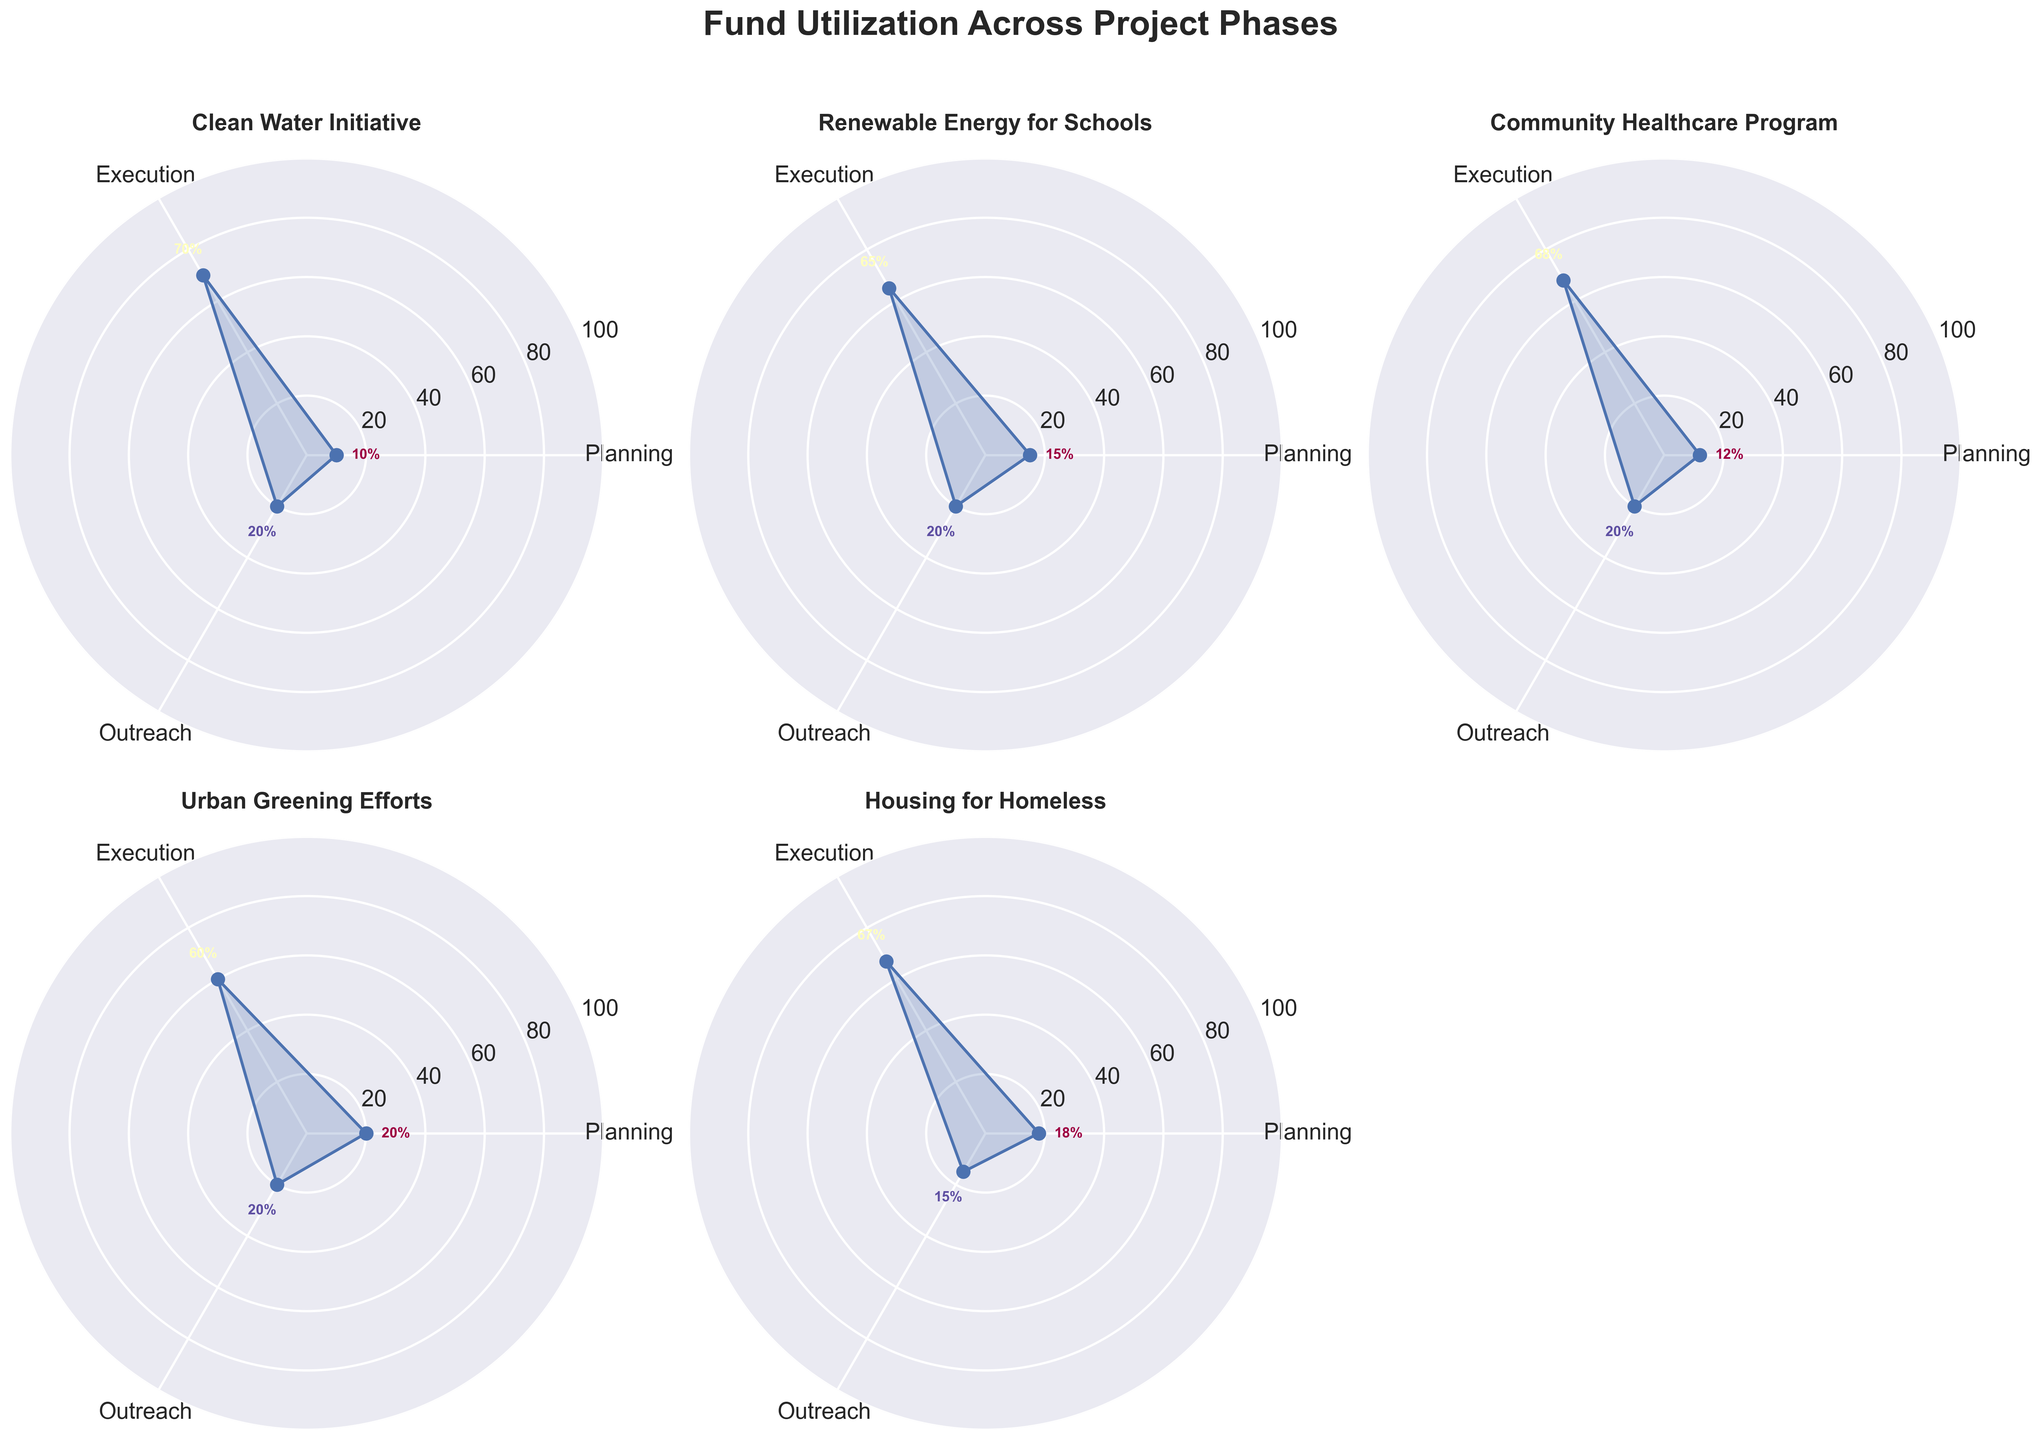Which project has the highest percentage of funds allocated to planning? To determine which project allocates the highest percentage of funds to planning, we compare the planning percentages across all the projects in the chart. The highest planning percentage is 20% for the "Urban Greening Efforts" project.
Answer: Urban Greening Efforts Which phase generally receives the least funding across all projects? By observing the plotted percentages across different phases (planning, execution, outreach) for all projects, the "Planning" phase tends to have the lowest percentages consistently across the projects.
Answer: Planning How does the fund allocation for the "Execution" phase in the "Clean Water Initiative" compare to the "Housing for Homeless" project? To compare the fund allocation in the execution phase, we look at the value of the percentage for each project. The "Execution" phase for "Clean Water Initiative" is 70%, while for "Housing for Homeless," it is 67%.
Answer: Clean Water Initiative has a higher execution percentage than Housing for Homeless Which project has the most balanced distribution of funds across the three phases? A balanced distribution would have the percentages for each phase close to each other. "Housing for Homeless" has percentages of 18%, 67%, and 15%, which is relatively more balanced compared to other projects with higher disparity, e.g., the "Clean Water Initiative" (10%, 70%, 20%).
Answer: Housing for Homeless Are there any projects with equal funding percentages for any phases? We are looking for projects where two or more phases have the same percentage values. None of the projects show equal percentages for any two phases.
Answer: No What is the difference in the outreach funding between the "Community Healthcare Program" and the "Urban Greening Efforts"? The outreach funding for both "Community Healthcare Program" and "Urban Greening Efforts" is 20%, so the difference in their percentages is 0%.
Answer: 0% Which project has the lowest percentage for the "Execution" phase? By comparing the "Execution" phase percentages, "Urban Greening Efforts" has the lowest execution phase funding percentage at 60%.
Answer: Urban Greening Efforts If you sum up the planning and outreach phases' percentages, which project has the highest combined value? To find the project with the highest combined planning and outreach percentages, we calculate:
- Clean Water Initiative: 10 + 20 = 30
- Renewable Energy for Schools: 15 + 20 = 35
- Community Healthcare Program: 12 + 20 = 32
- Urban Greening Efforts: 20 + 20 = 40
- Housing for Homeless: 18 + 15 = 33
"Urban Greening Efforts" has the highest combined value at 40%.
Answer: Urban Greening Efforts 